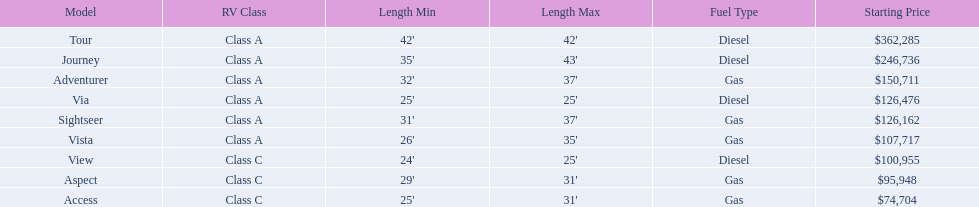Which of the models in the table use diesel fuel? Tour, Journey, Via, View. Of these models, which are class a? Tour, Journey, Via. Which of them are greater than 35' in length? Tour, Journey. Which of the two models is more expensive? Tour. 